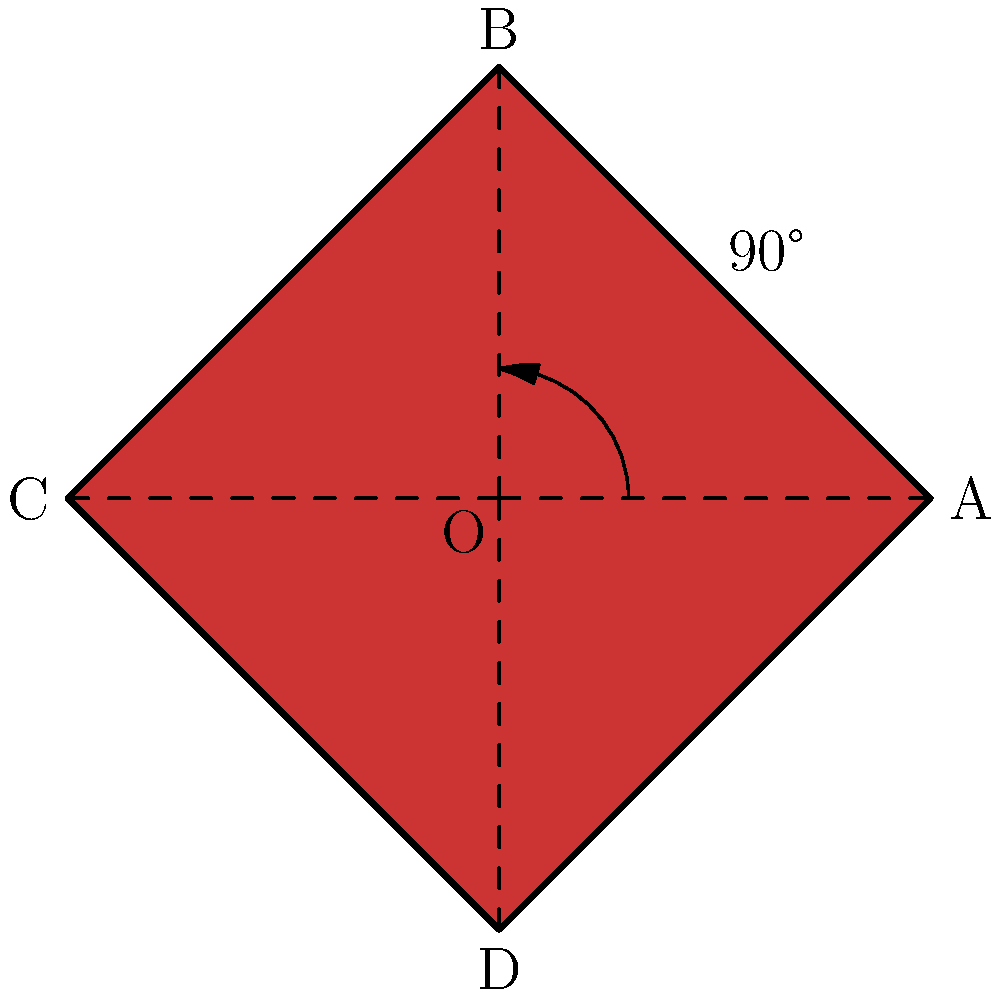The iconic red square logo of the '90s cult classic "Pulp Fiction" is shown above. If this logo is rotated 90° counterclockwise around point O, what will be the new position of point A? To solve this problem, let's follow these steps:

1) First, recall that a 90° counterclockwise rotation around the origin transforms a point $(x,y)$ to $(-y,x)$.

2) In this case, point A is at coordinates $(1,0)$ before the rotation.

3) Applying the rotation transformation:
   $x = 1$ becomes $y = 1$
   $y = 0$ becomes $x = -0 = 0$

4) Therefore, the new coordinates of A after rotation will be $(0,1)$.

5) Looking at the diagram, we can see that these are the coordinates of point B.

So, after a 90° counterclockwise rotation around O, point A will move to the position currently occupied by point B.
Answer: B 